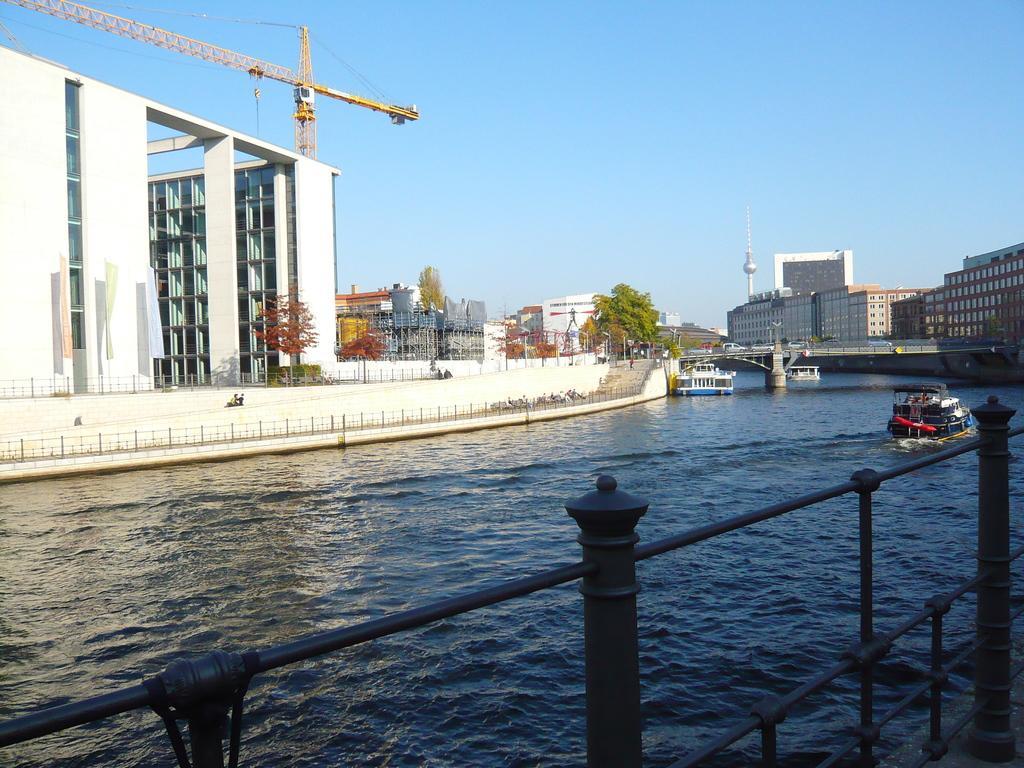Can you describe this image briefly? In this image there is the sky, there are buildings towards the right of the image, there is a bridge, there is a river, there are boats on the river, there is a building to the left of the image, there are trees, there are plants, there is a grill truncated towards the right of the image. 